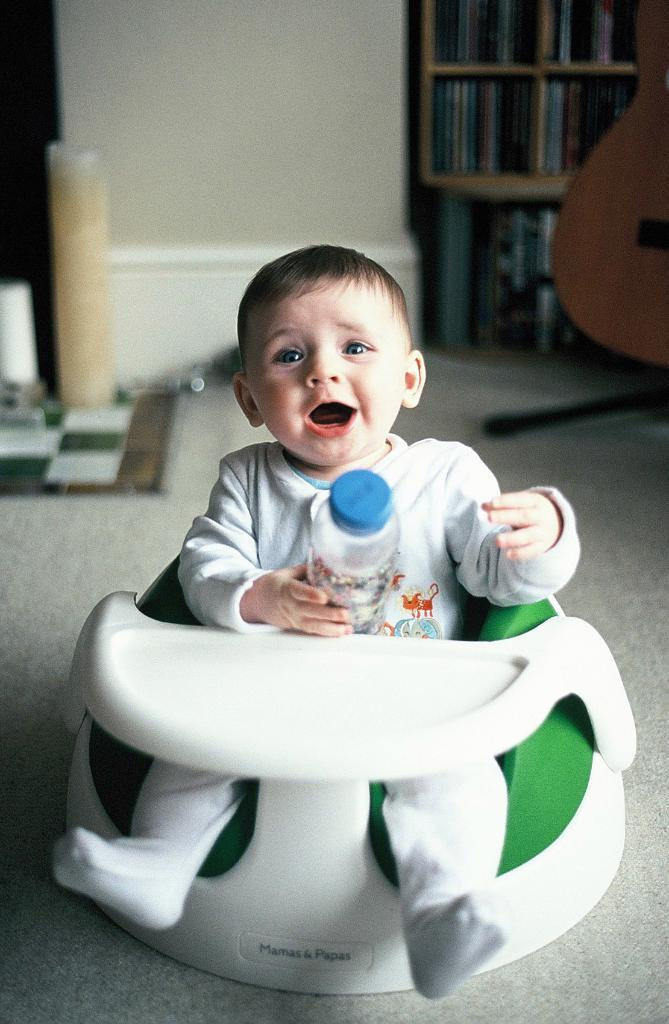What is the main subject of the image? There is a baby in the image. What is the baby holding? The baby is holding a bottle. Where is the baby sitting? The baby is sitting on a chair. What is the position of the chair? The chair is on the floor. What can be seen in the background of the image? There are books in racks and other objects visible in the background of the image. What type of cart is visible in the image? There is no cart present in the image. What is the baby's opinion on the books in the background? The baby's opinion cannot be determined from the image, as it does not show any facial expressions or reactions to the books. 